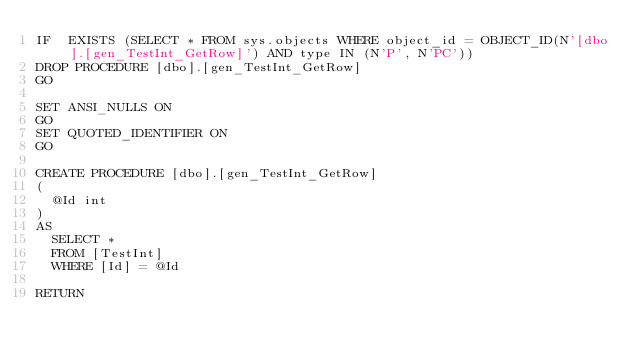Convert code to text. <code><loc_0><loc_0><loc_500><loc_500><_SQL_>IF  EXISTS (SELECT * FROM sys.objects WHERE object_id = OBJECT_ID(N'[dbo].[gen_TestInt_GetRow]') AND type IN (N'P', N'PC'))
DROP PROCEDURE [dbo].[gen_TestInt_GetRow]
GO

SET ANSI_NULLS ON
GO
SET QUOTED_IDENTIFIER ON
GO

CREATE PROCEDURE [dbo].[gen_TestInt_GetRow]
(
	@Id int
)
AS
	SELECT *
	FROM [TestInt]
	WHERE [Id] = @Id
	
RETURN
</code> 